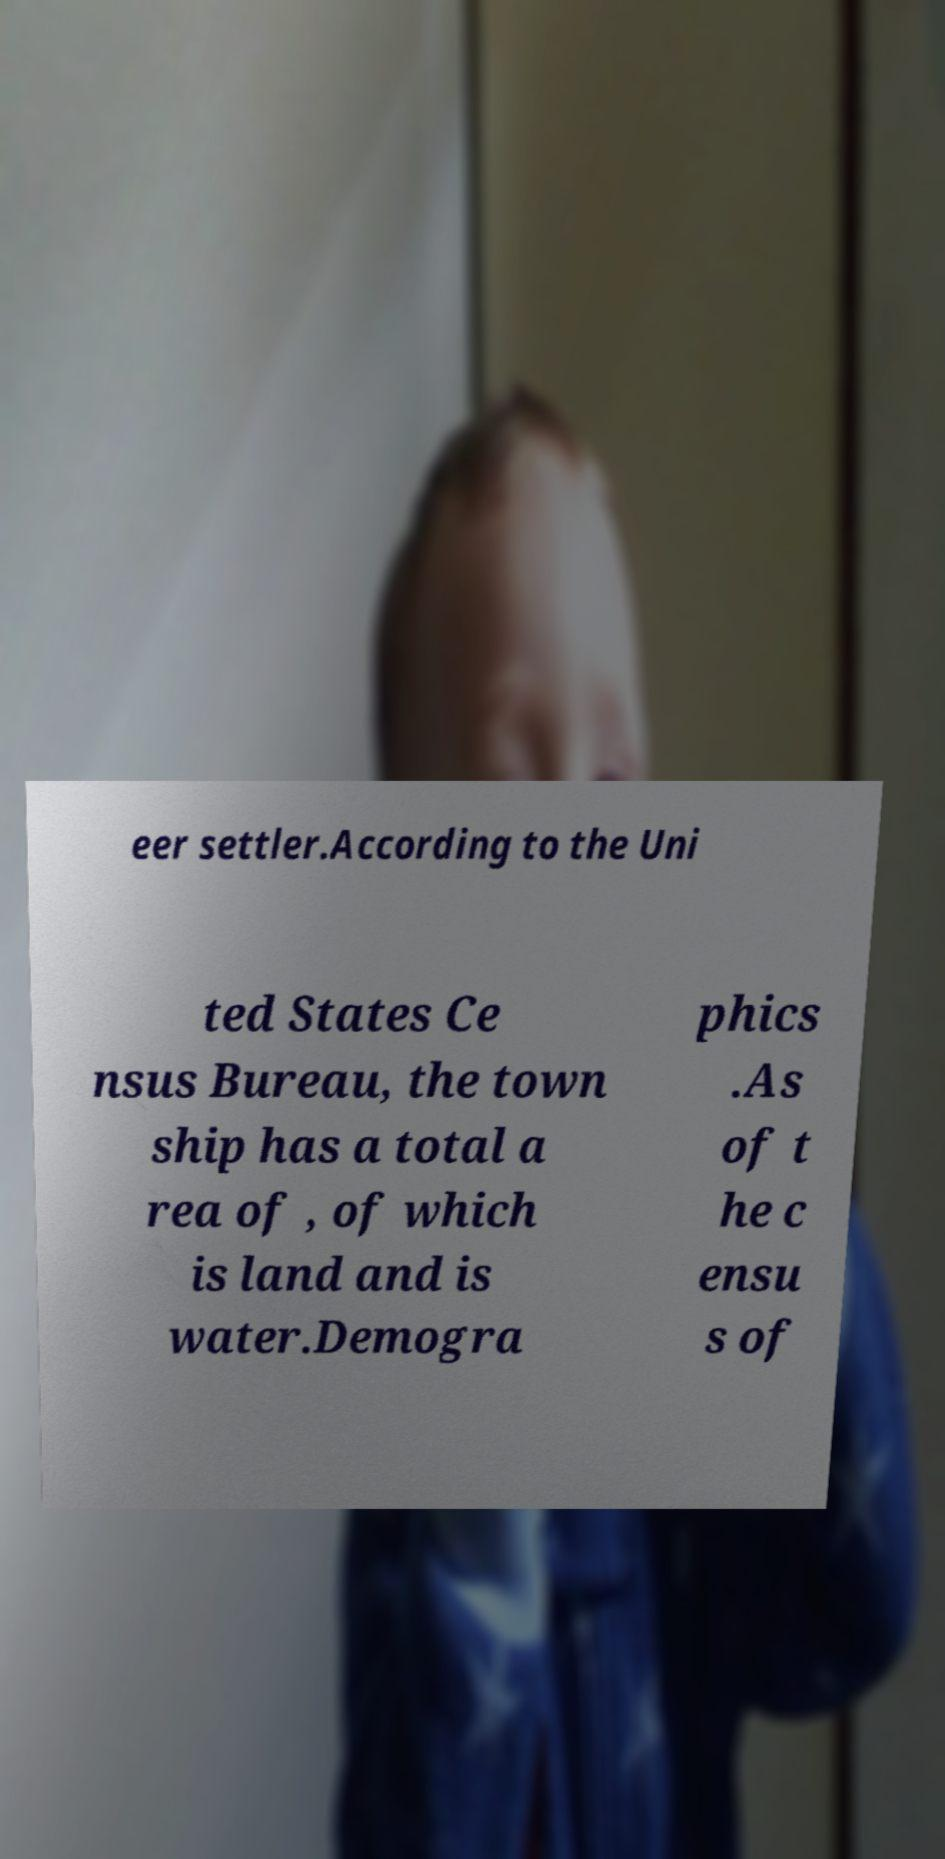Can you read and provide the text displayed in the image?This photo seems to have some interesting text. Can you extract and type it out for me? eer settler.According to the Uni ted States Ce nsus Bureau, the town ship has a total a rea of , of which is land and is water.Demogra phics .As of t he c ensu s of 